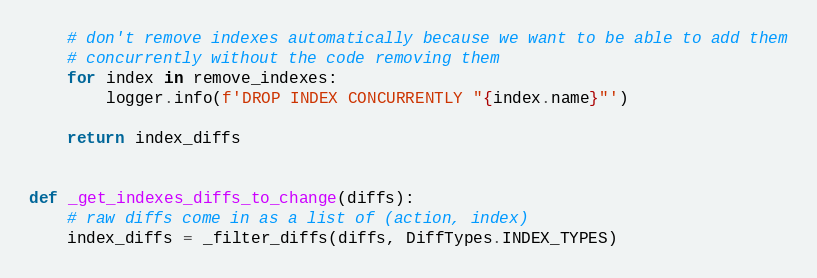<code> <loc_0><loc_0><loc_500><loc_500><_Python_>
    # don't remove indexes automatically because we want to be able to add them
    # concurrently without the code removing them
    for index in remove_indexes:
        logger.info(f'DROP INDEX CONCURRENTLY "{index.name}"')

    return index_diffs


def _get_indexes_diffs_to_change(diffs):
    # raw diffs come in as a list of (action, index)
    index_diffs = _filter_diffs(diffs, DiffTypes.INDEX_TYPES)</code> 